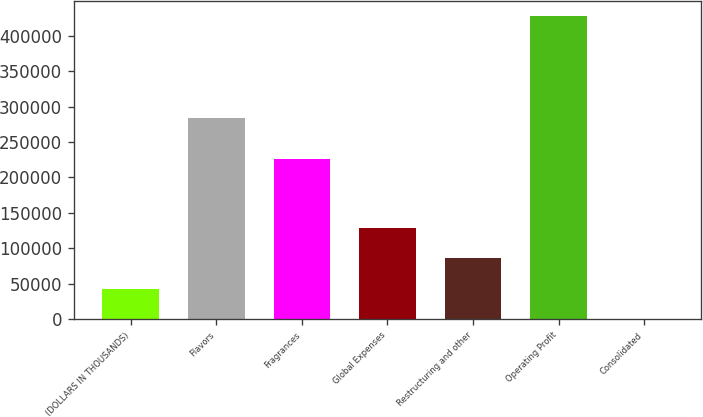Convert chart. <chart><loc_0><loc_0><loc_500><loc_500><bar_chart><fcel>(DOLLARS IN THOUSANDS)<fcel>Flavors<fcel>Fragrances<fcel>Global Expenses<fcel>Restructuring and other<fcel>Operating Profit<fcel>Consolidated<nl><fcel>42786.7<fcel>284246<fcel>226560<fcel>128329<fcel>85558<fcel>427729<fcel>15.3<nl></chart> 